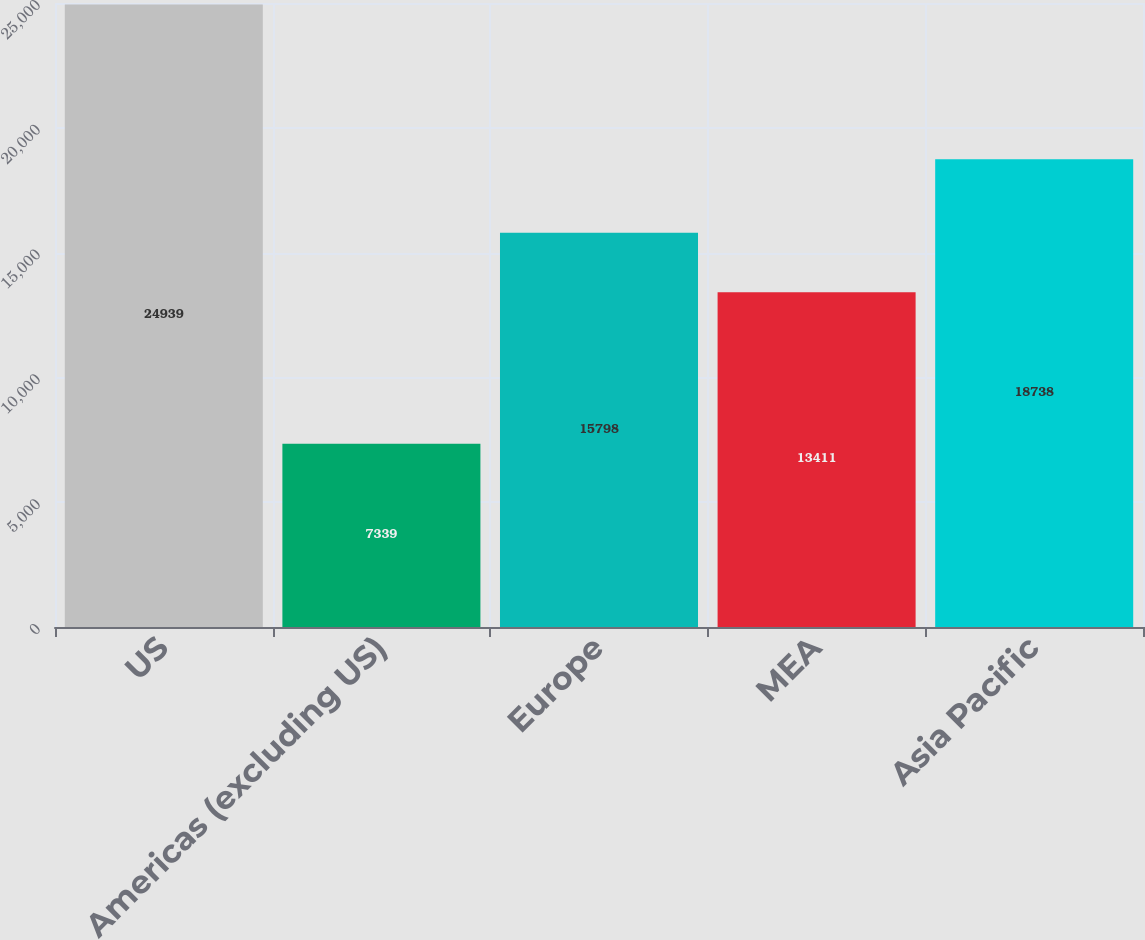<chart> <loc_0><loc_0><loc_500><loc_500><bar_chart><fcel>US<fcel>Americas (excluding US)<fcel>Europe<fcel>MEA<fcel>Asia Pacific<nl><fcel>24939<fcel>7339<fcel>15798<fcel>13411<fcel>18738<nl></chart> 